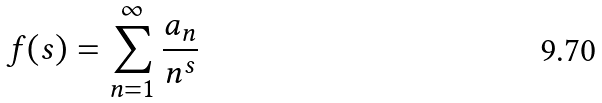<formula> <loc_0><loc_0><loc_500><loc_500>f ( s ) = \sum _ { n = 1 } ^ { \infty } \frac { a _ { n } } { n ^ { s } }</formula> 